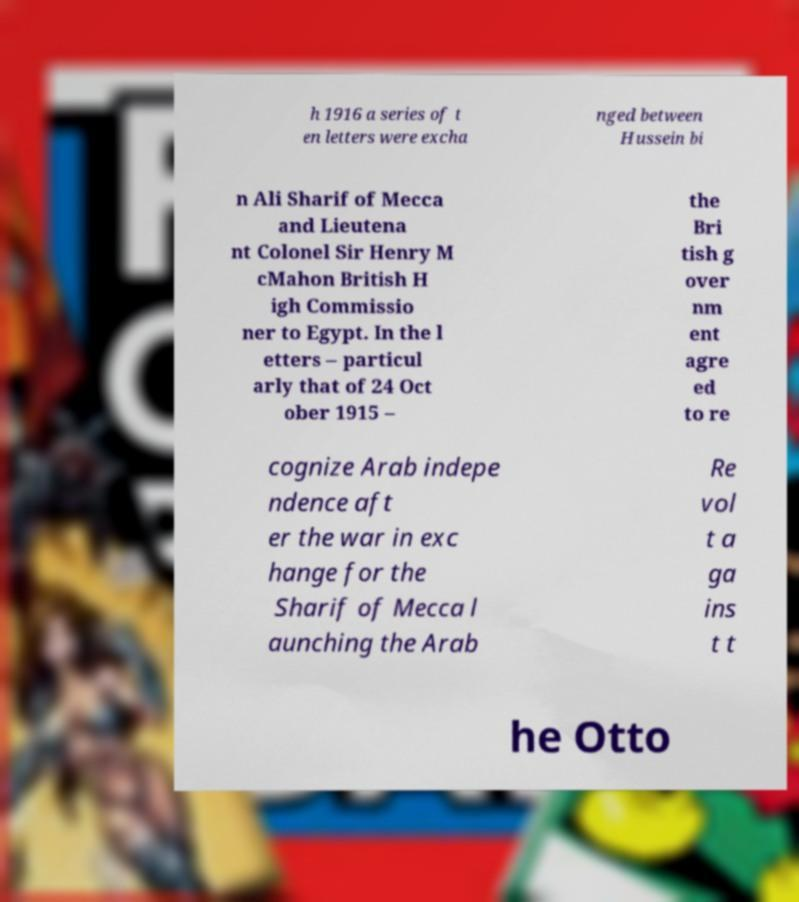For documentation purposes, I need the text within this image transcribed. Could you provide that? h 1916 a series of t en letters were excha nged between Hussein bi n Ali Sharif of Mecca and Lieutena nt Colonel Sir Henry M cMahon British H igh Commissio ner to Egypt. In the l etters – particul arly that of 24 Oct ober 1915 – the Bri tish g over nm ent agre ed to re cognize Arab indepe ndence aft er the war in exc hange for the Sharif of Mecca l aunching the Arab Re vol t a ga ins t t he Otto 